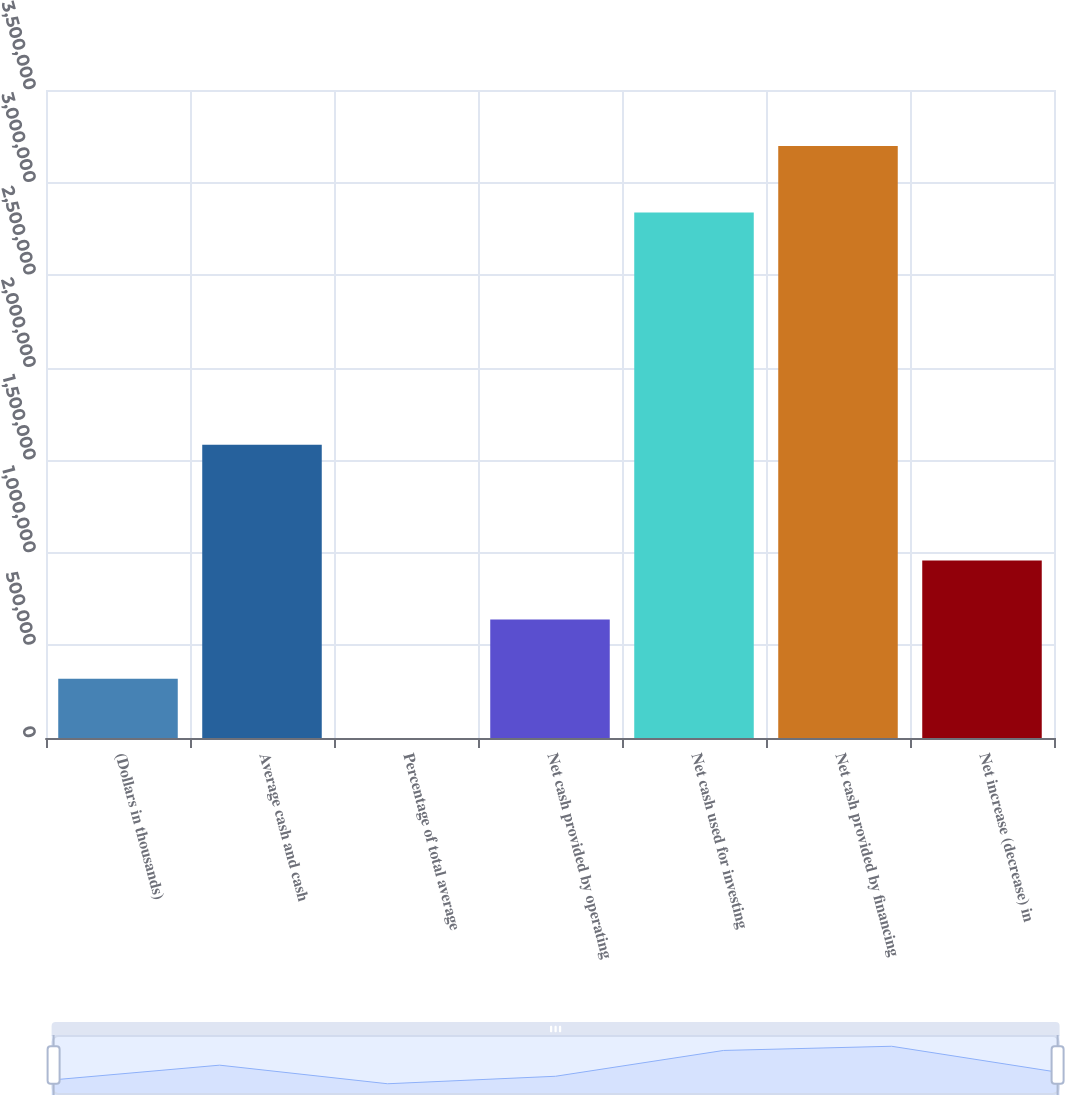<chart> <loc_0><loc_0><loc_500><loc_500><bar_chart><fcel>(Dollars in thousands)<fcel>Average cash and cash<fcel>Percentage of total average<fcel>Net cash provided by operating<fcel>Net cash used for investing<fcel>Net cash provided by financing<fcel>Net increase (decrease) in<nl><fcel>319707<fcel>1.58404e+06<fcel>6.8<fcel>639407<fcel>2.83899e+06<fcel>3.19701e+06<fcel>959107<nl></chart> 